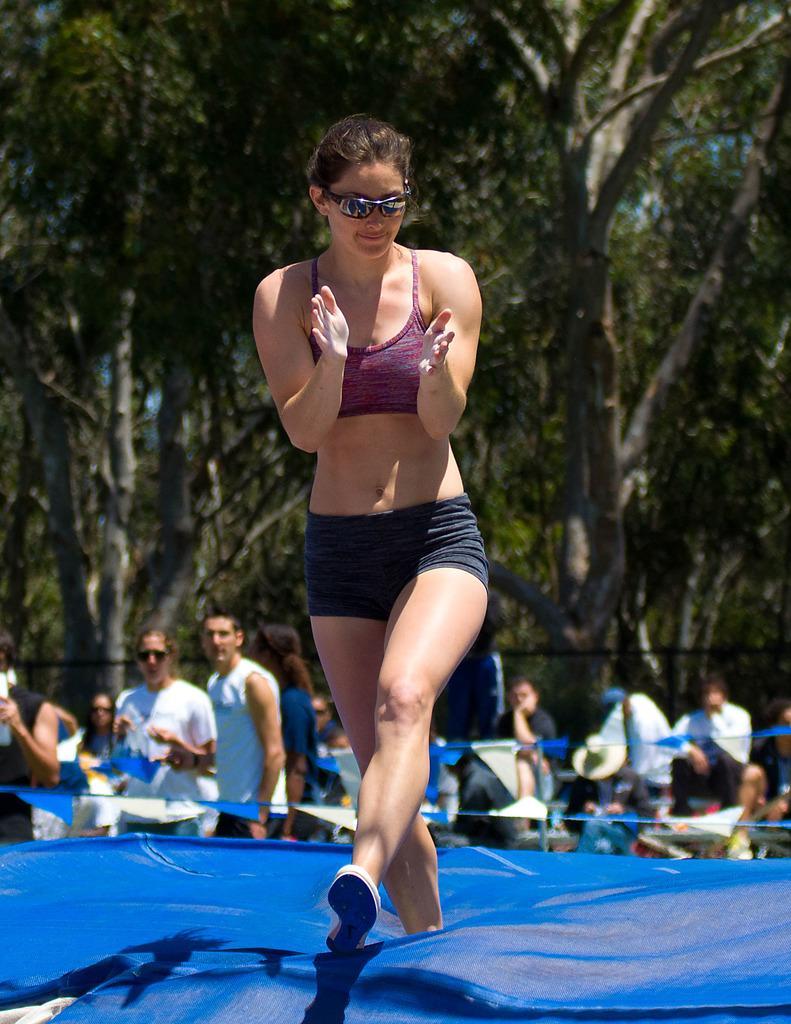How would you summarize this image in a sentence or two? In the image there is a woman clapping and moving on a blue surface, behind the woman there are few other people and in the background there are tall trees. 